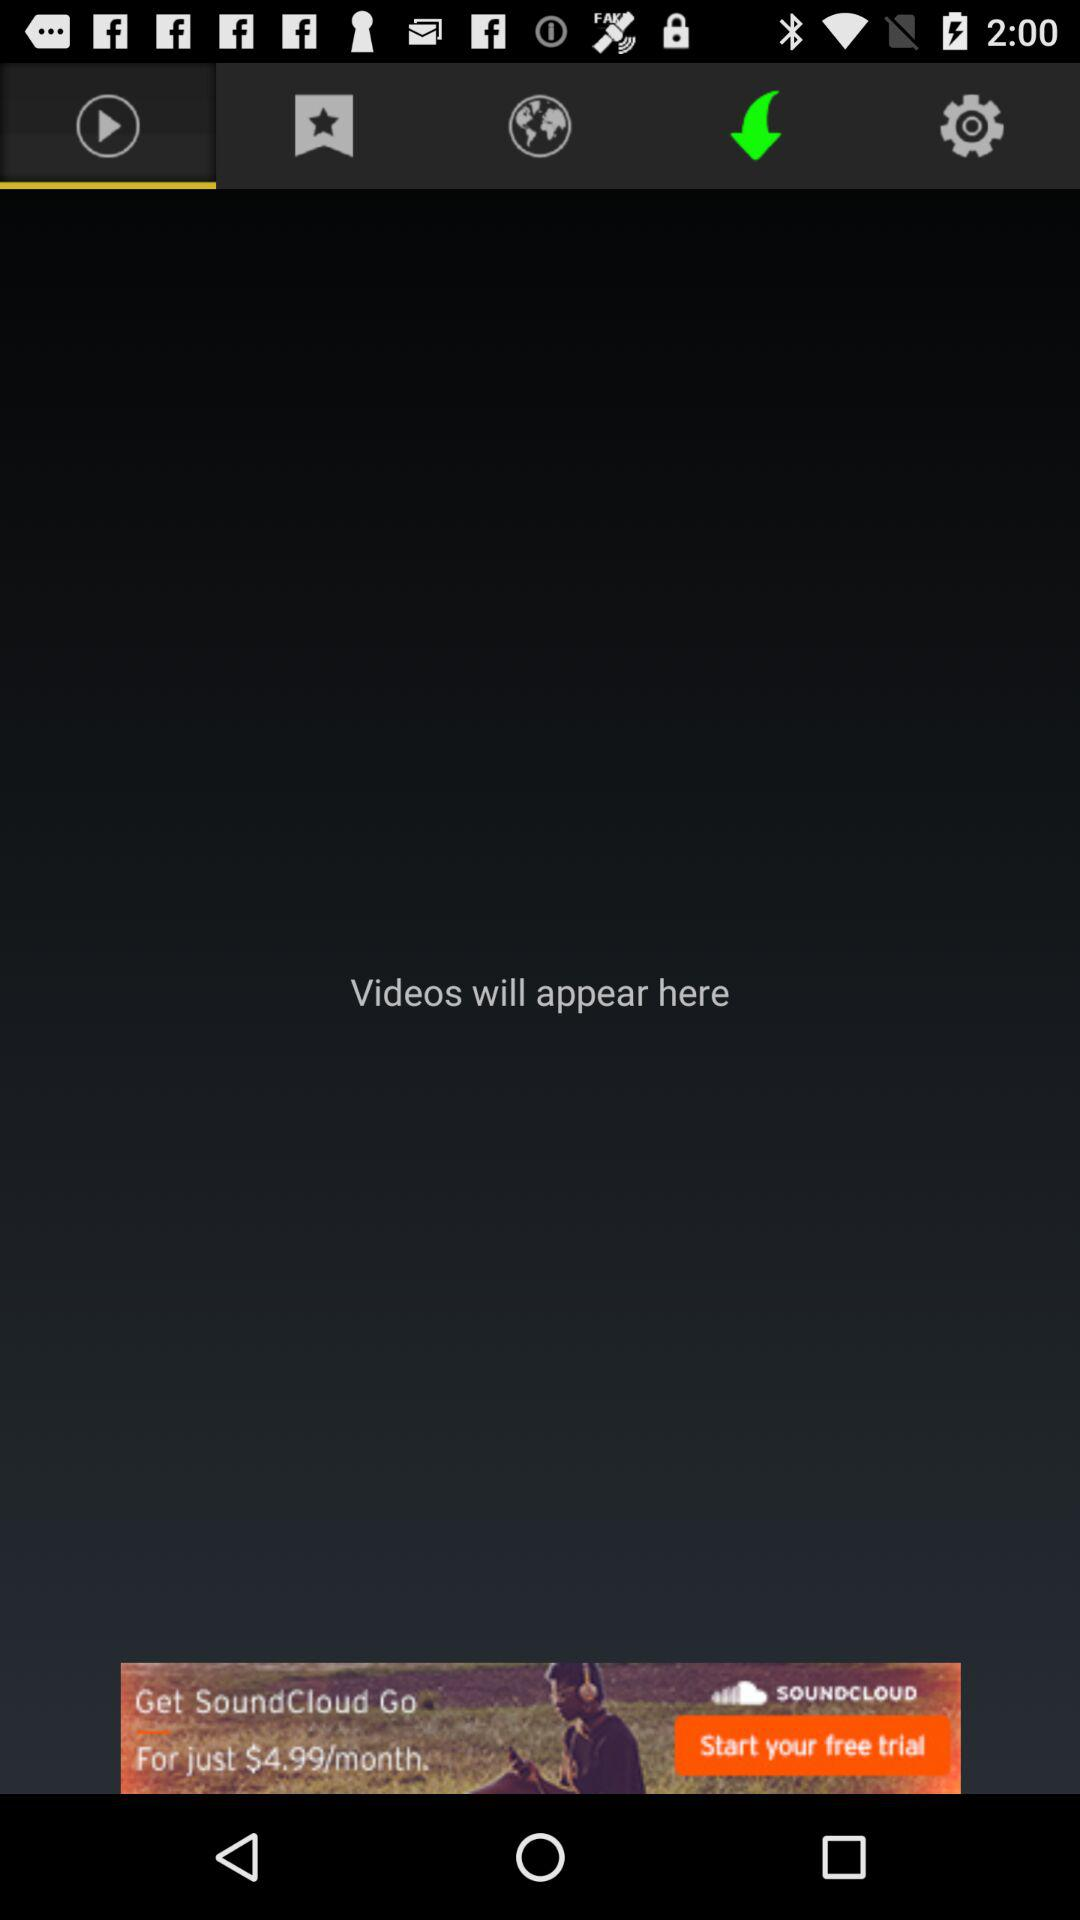Which tab is selected? The selected tab is "Videos". 